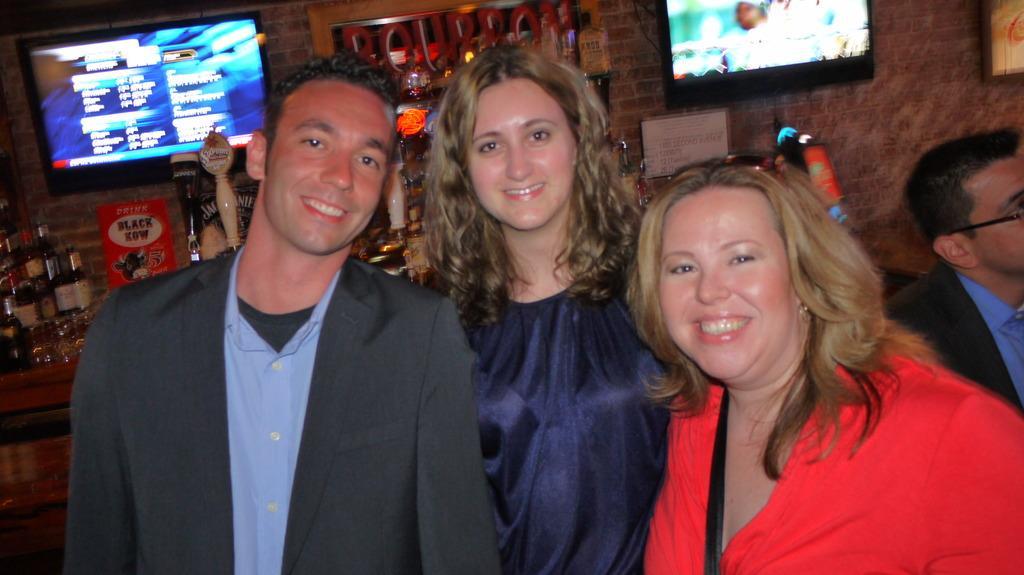How would you summarize this image in a sentence or two? In the image there are three people standing in the foreground and posing for the photo, behind them there are some alcohol bottles and glasses, in the background there is a wall and there are two screens attached to the wall. 